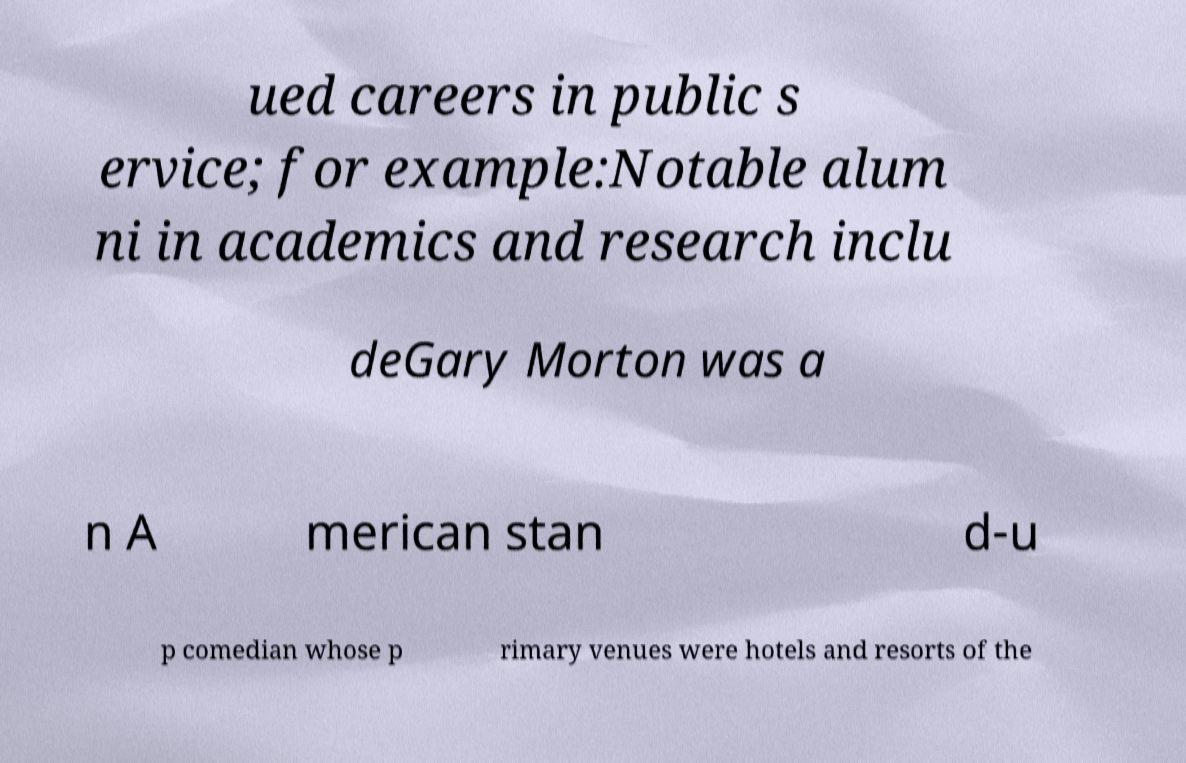Can you accurately transcribe the text from the provided image for me? ued careers in public s ervice; for example:Notable alum ni in academics and research inclu deGary Morton was a n A merican stan d-u p comedian whose p rimary venues were hotels and resorts of the 